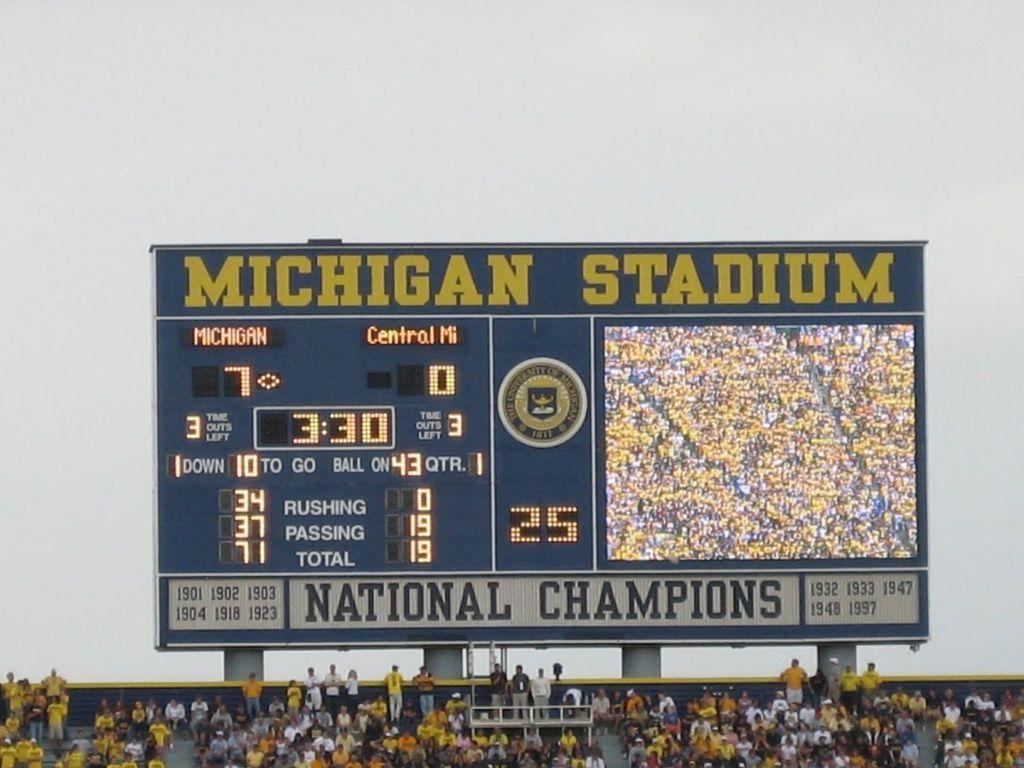<image>
Render a clear and concise summary of the photo. The scoreboard at Michigan Stadium shows that Michigan currently has 7 points. 